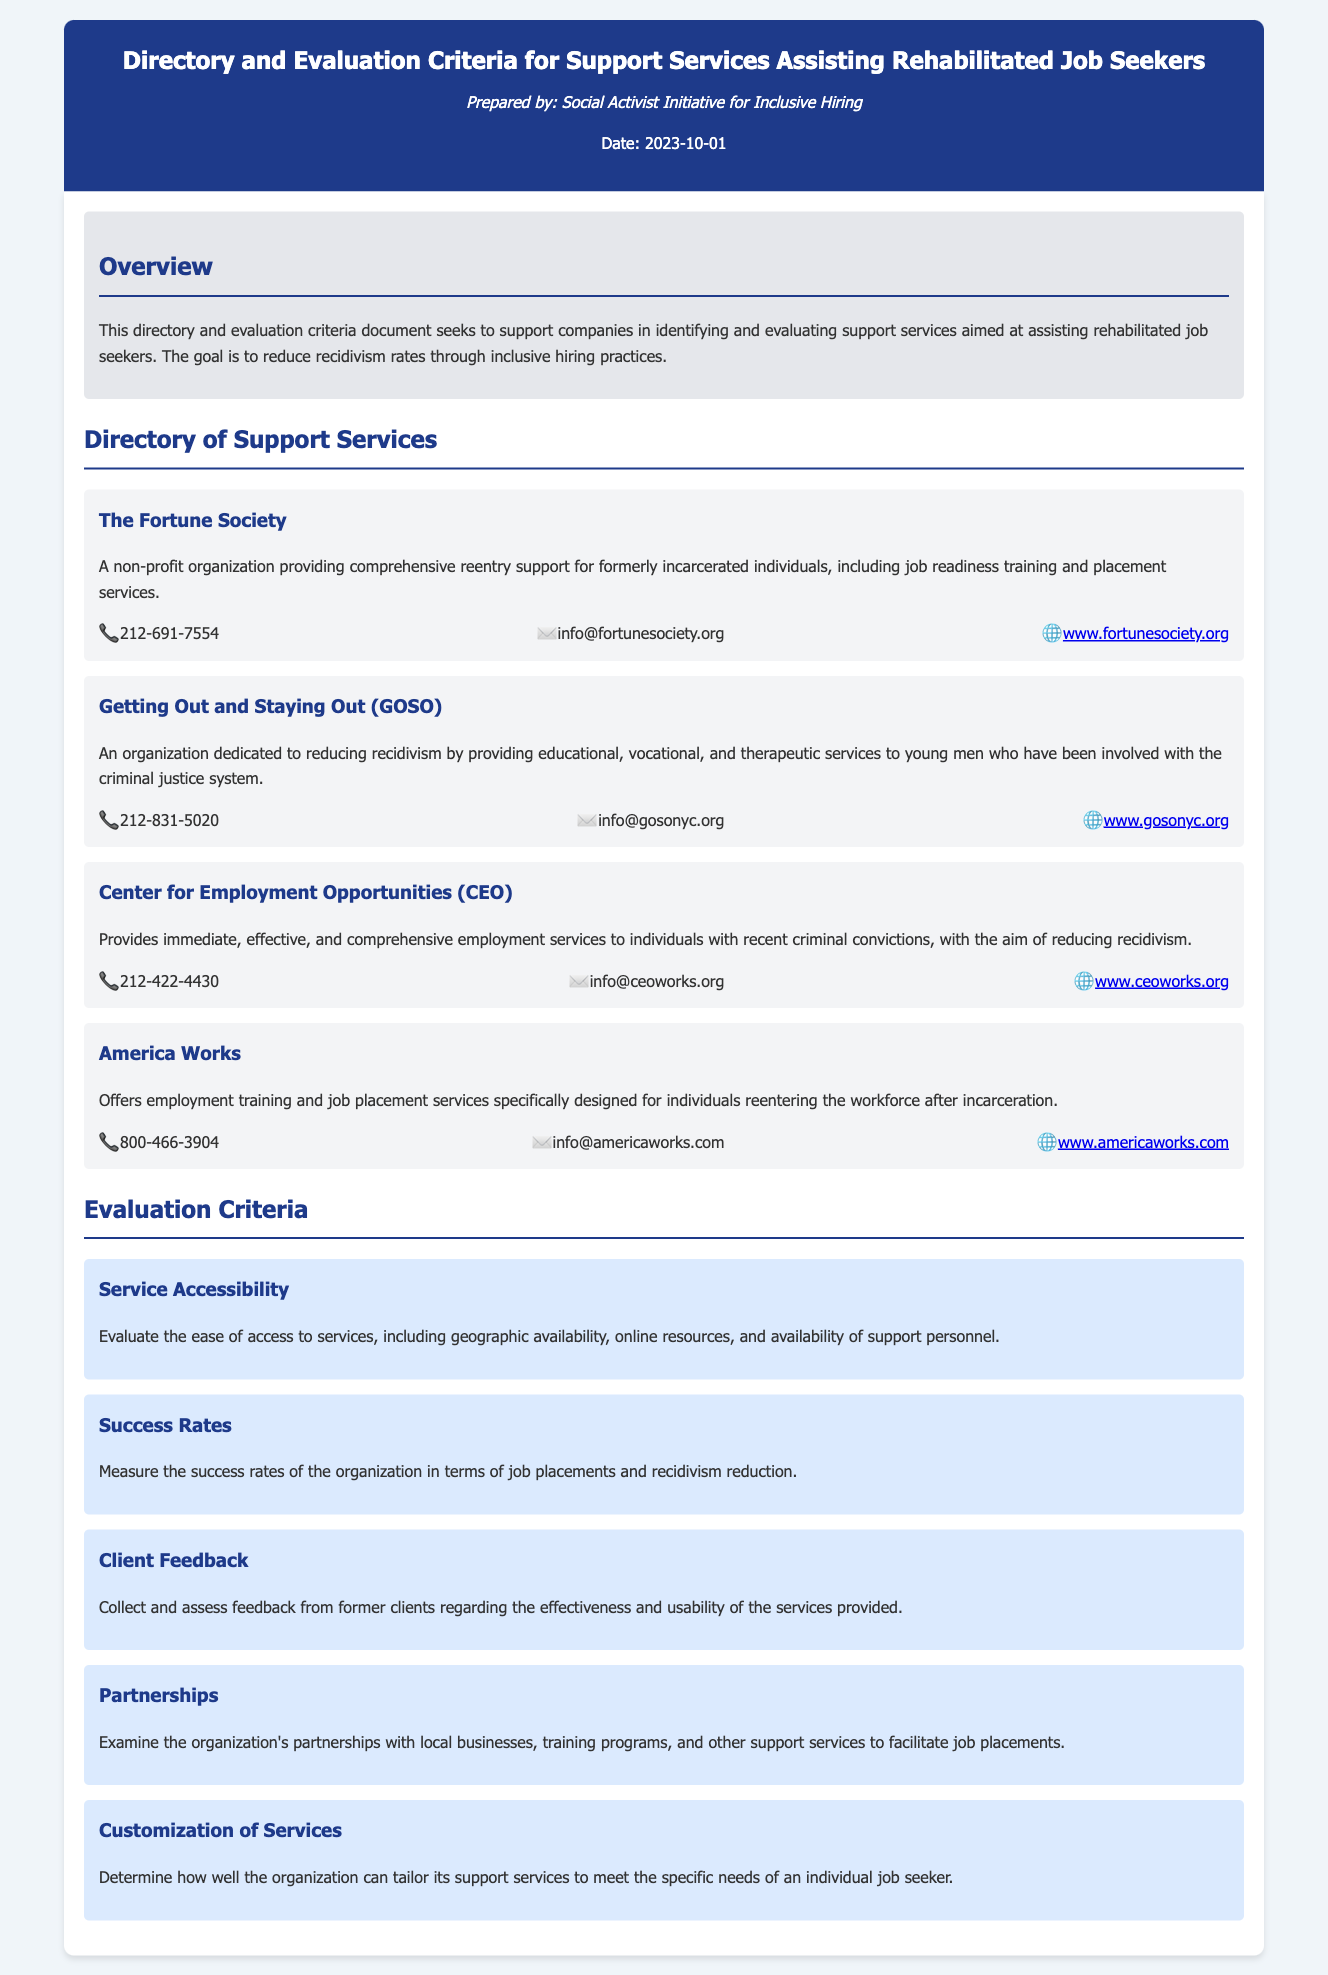what is the title of the document? The title of the document is presented at the top of the header section.
Answer: Directory and Evaluation Criteria for Support Services Assisting Rehabilitated Job Seekers who prepared the document? The prepared by section indicates the entity responsible for creating the document.
Answer: Social Activist Initiative for Inclusive Hiring when was the document prepared? The date mentioned in the header indicates when the document was created.
Answer: 2023-10-01 how many services are listed in the directory? The document contains descriptions for four different support services.
Answer: 4 what is the main goal of the document? The overview section outlines the primary objective of the document.
Answer: To reduce recidivism rates through inclusive hiring practices which organization focuses on young men involved with the criminal justice system? The document provides specific information about organizations and their target demographics.
Answer: Getting Out and Staying Out (GOSO) what factor is considered for evaluating service effectiveness? The evaluation criteria section lists several factors to assess the services.
Answer: Success Rates name one criterion used for evaluating support services. The evaluation criteria section provides multiple criteria that can be selected as answers.
Answer: Service Accessibility what type of organization is The Fortune Society? The document specifies the category of support services provided by various organizations.
Answer: Non-profit organization 